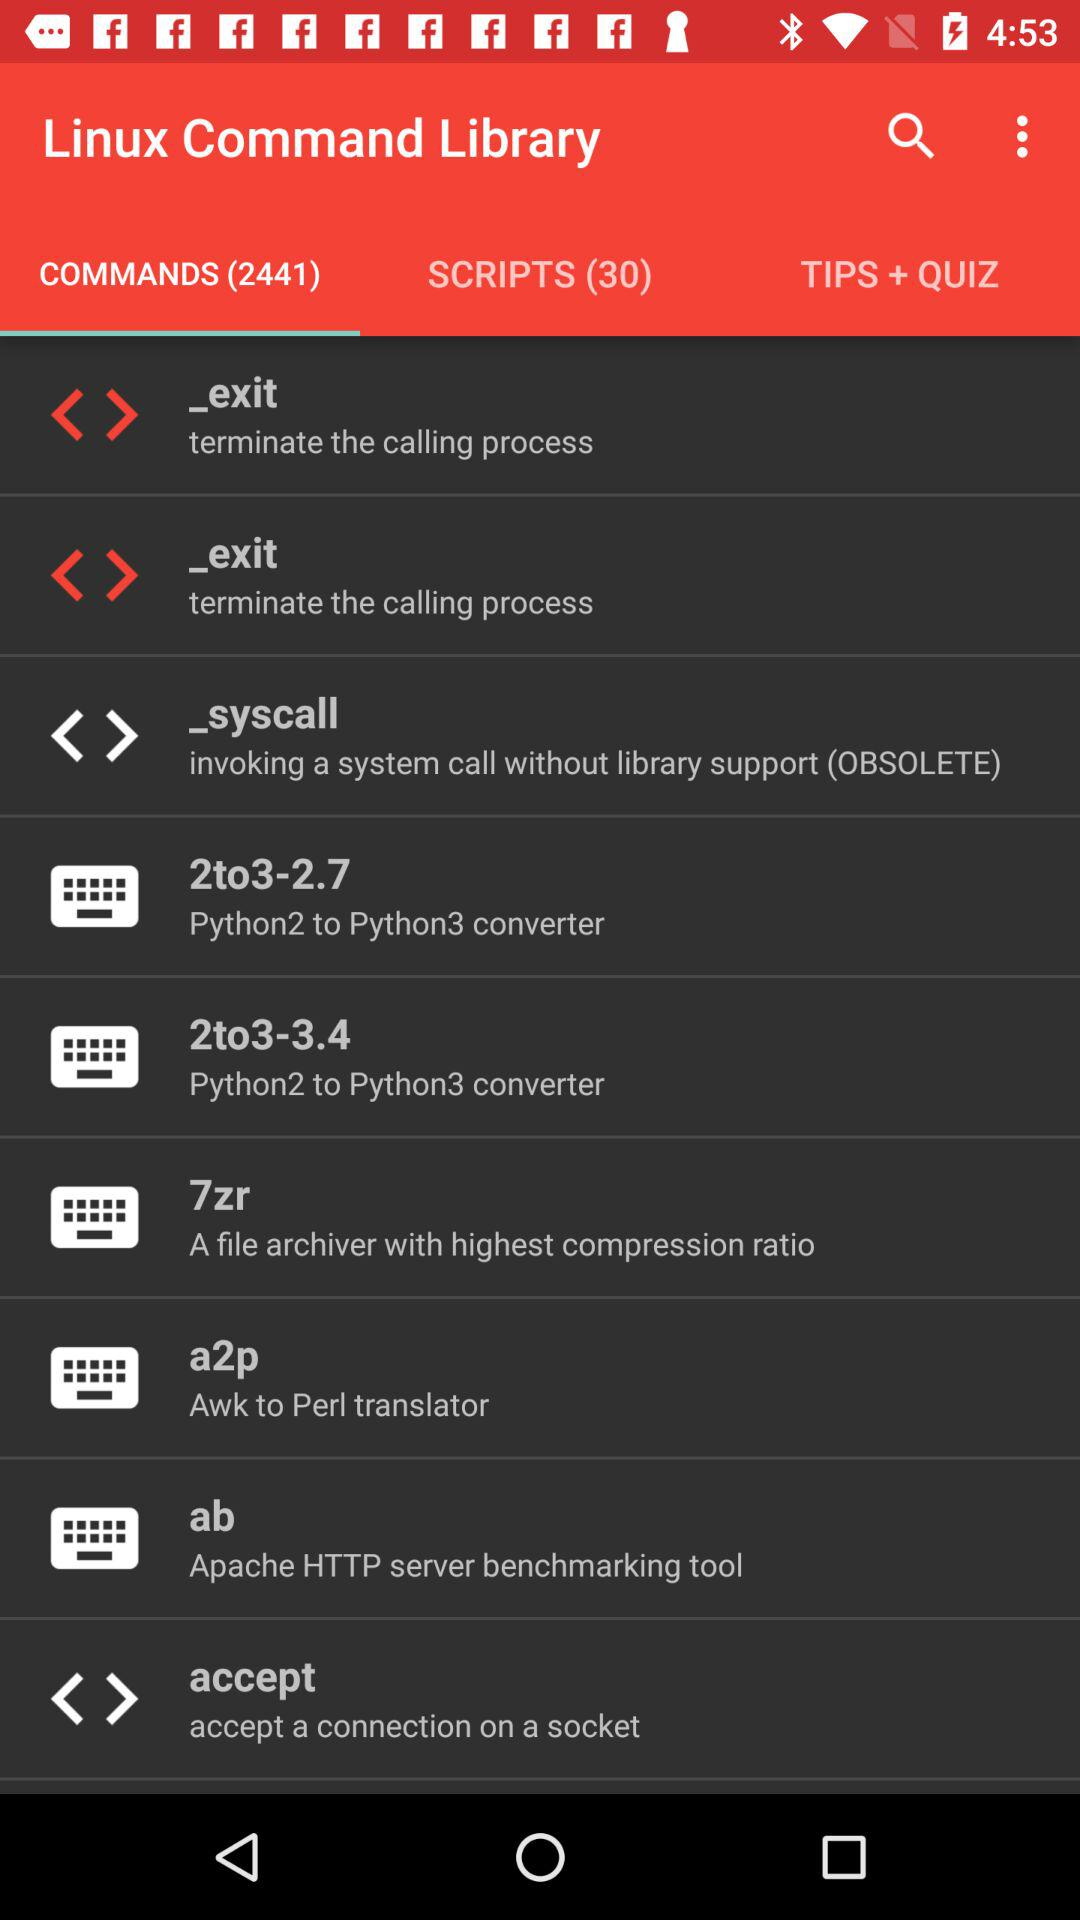In the Linux Command Library, how many Tips+ Quiz are there?
When the provided information is insufficient, respond with <no answer>. <no answer> 